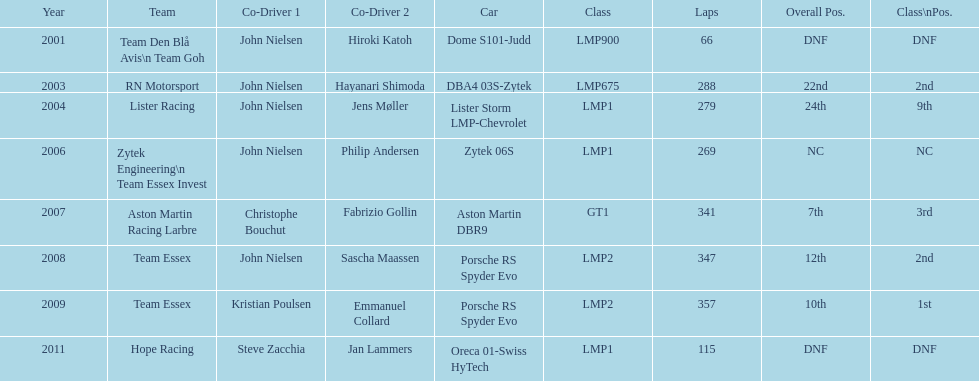In 2008 and what other year was casper elgaard on team essex for the 24 hours of le mans? 2009. 